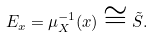<formula> <loc_0><loc_0><loc_500><loc_500>E _ { x } = \mu _ { X } ^ { - 1 } ( x ) \cong \tilde { S } .</formula> 